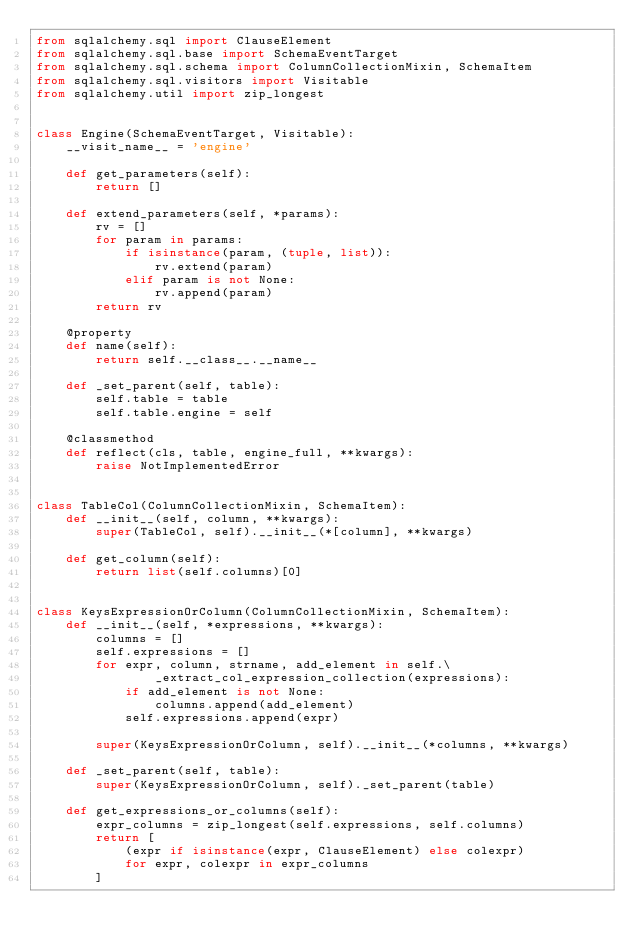<code> <loc_0><loc_0><loc_500><loc_500><_Python_>from sqlalchemy.sql import ClauseElement
from sqlalchemy.sql.base import SchemaEventTarget
from sqlalchemy.sql.schema import ColumnCollectionMixin, SchemaItem
from sqlalchemy.sql.visitors import Visitable
from sqlalchemy.util import zip_longest


class Engine(SchemaEventTarget, Visitable):
    __visit_name__ = 'engine'

    def get_parameters(self):
        return []

    def extend_parameters(self, *params):
        rv = []
        for param in params:
            if isinstance(param, (tuple, list)):
                rv.extend(param)
            elif param is not None:
                rv.append(param)
        return rv

    @property
    def name(self):
        return self.__class__.__name__

    def _set_parent(self, table):
        self.table = table
        self.table.engine = self

    @classmethod
    def reflect(cls, table, engine_full, **kwargs):
        raise NotImplementedError


class TableCol(ColumnCollectionMixin, SchemaItem):
    def __init__(self, column, **kwargs):
        super(TableCol, self).__init__(*[column], **kwargs)

    def get_column(self):
        return list(self.columns)[0]


class KeysExpressionOrColumn(ColumnCollectionMixin, SchemaItem):
    def __init__(self, *expressions, **kwargs):
        columns = []
        self.expressions = []
        for expr, column, strname, add_element in self.\
                _extract_col_expression_collection(expressions):
            if add_element is not None:
                columns.append(add_element)
            self.expressions.append(expr)

        super(KeysExpressionOrColumn, self).__init__(*columns, **kwargs)

    def _set_parent(self, table):
        super(KeysExpressionOrColumn, self)._set_parent(table)

    def get_expressions_or_columns(self):
        expr_columns = zip_longest(self.expressions, self.columns)
        return [
            (expr if isinstance(expr, ClauseElement) else colexpr)
            for expr, colexpr in expr_columns
        ]
</code> 